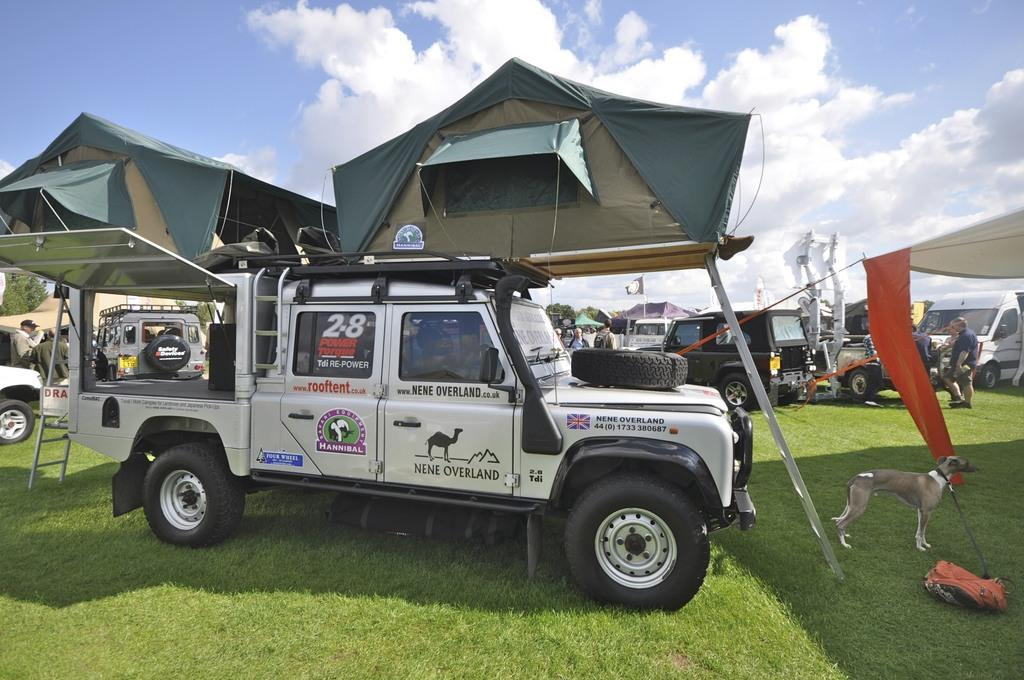What type of vehicles can be seen in the image? There are vehicles on a grassland in the image. What animal is present in the image? There is a dog in the image. Can you describe the people in the background of the image? There are people standing in the background of the image. What is visible in the background of the image besides the people? The sky is visible in the background of the image. What type of soup is being served to the dog in the image? There is no soup present in the image, and the dog is not being served anything. 